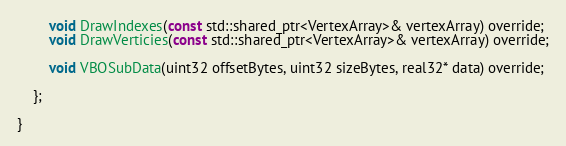<code> <loc_0><loc_0><loc_500><loc_500><_C_>		void DrawIndexes(const std::shared_ptr<VertexArray>& vertexArray) override;
		void DrawVerticies(const std::shared_ptr<VertexArray>& vertexArray) override;

		void VBOSubData(uint32 offsetBytes, uint32 sizeBytes, real32* data) override;

	};

}</code> 